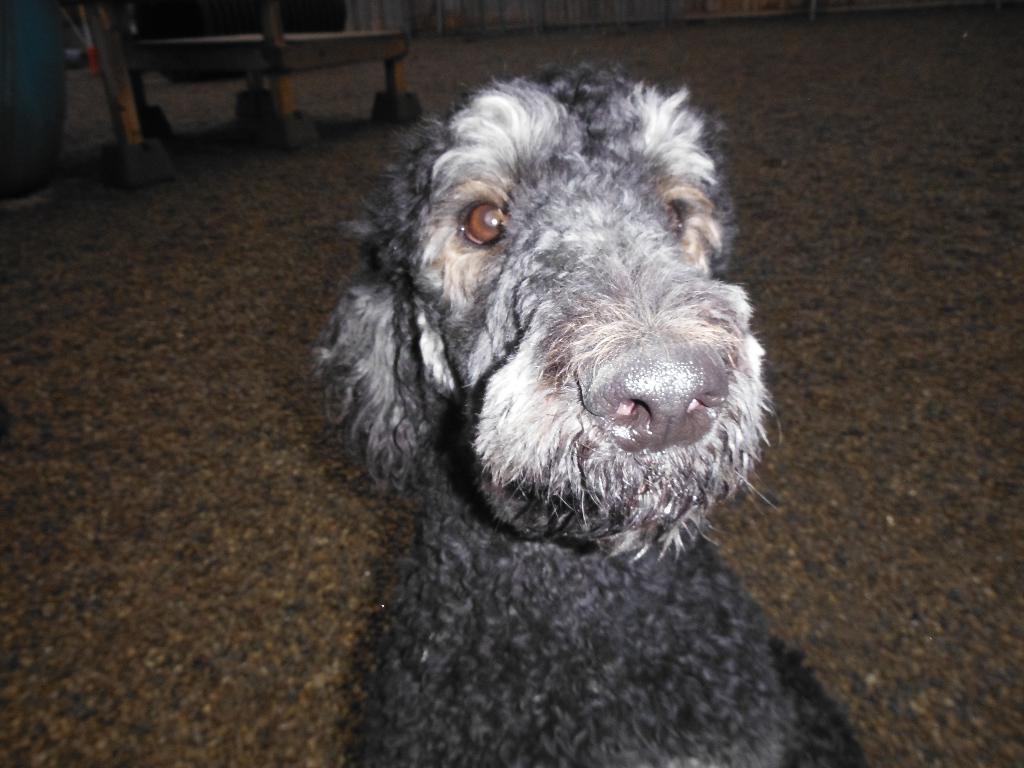Please provide a concise description of this image. This image consists of a dog in black color. At the bottom, there is a floor. In the background, we can see a curtain. To the left, it looks like there are wooden sticks. 